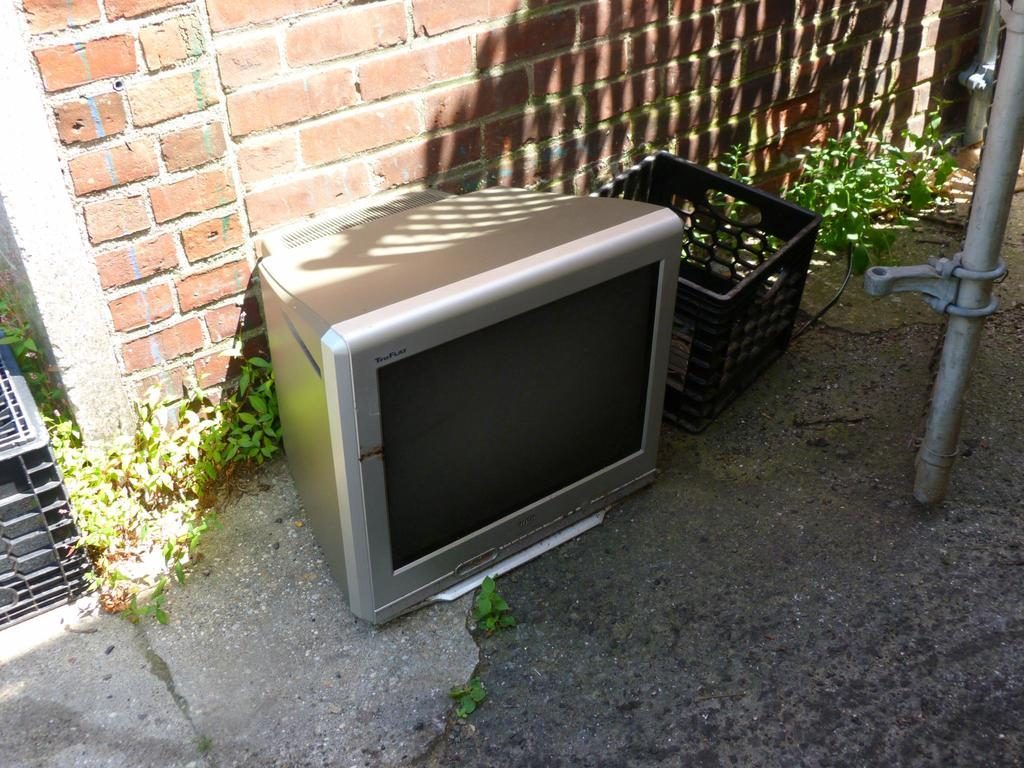What electronic device is present in the image? There is a television in the image. Where is the television located? The television is on the floor. What other object can be seen in the image? There is a basket in the image. What type of natural environment is visible in the image? Grass is visible in the image. What type of structure is in the background of the image? There is a brick wall in the background of the image. What is located on the right side of the image? There is a pipe on the right side of the image. What type of flight is taking place in the image? There is no flight present in the image; it features a television on the floor, a basket, grass, a brick wall, and a pipe. What relation does the pipe have with the television in the image? The pipe is not related to the television in the image; it is a separate object located on the right side of the image. 